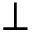Convert formula to latex. <formula><loc_0><loc_0><loc_500><loc_500>\perp</formula> 